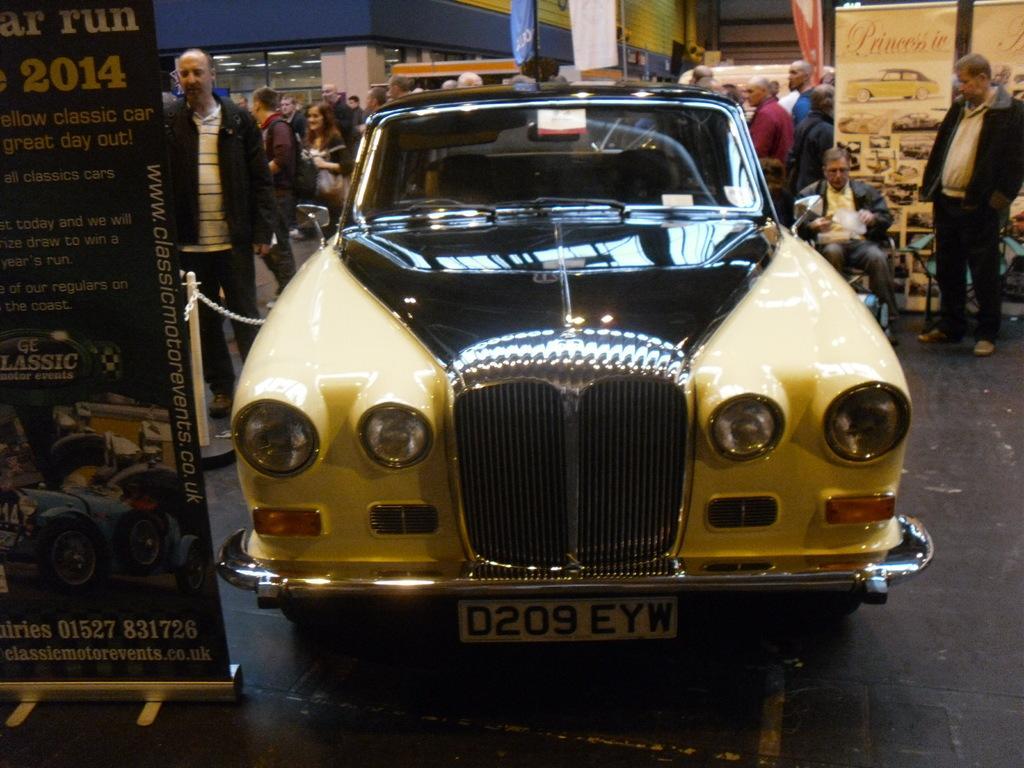Describe this image in one or two sentences. In this image we can see a car, to the left of the car we can see a poster, a small rod with a chain and on the right side of the car we can see a person sitting on a chair holding a paper and another person watching at him, there are a few people behind the car, a car window and a wall. 